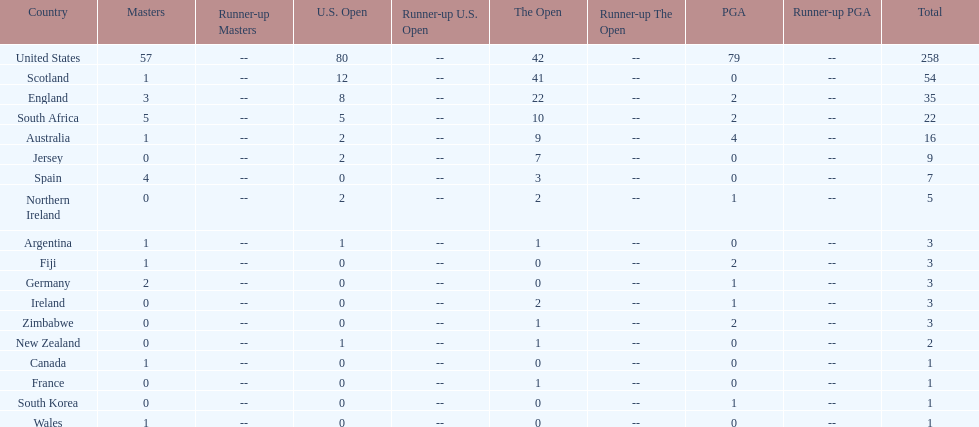How many total championships does spain have? 7. 